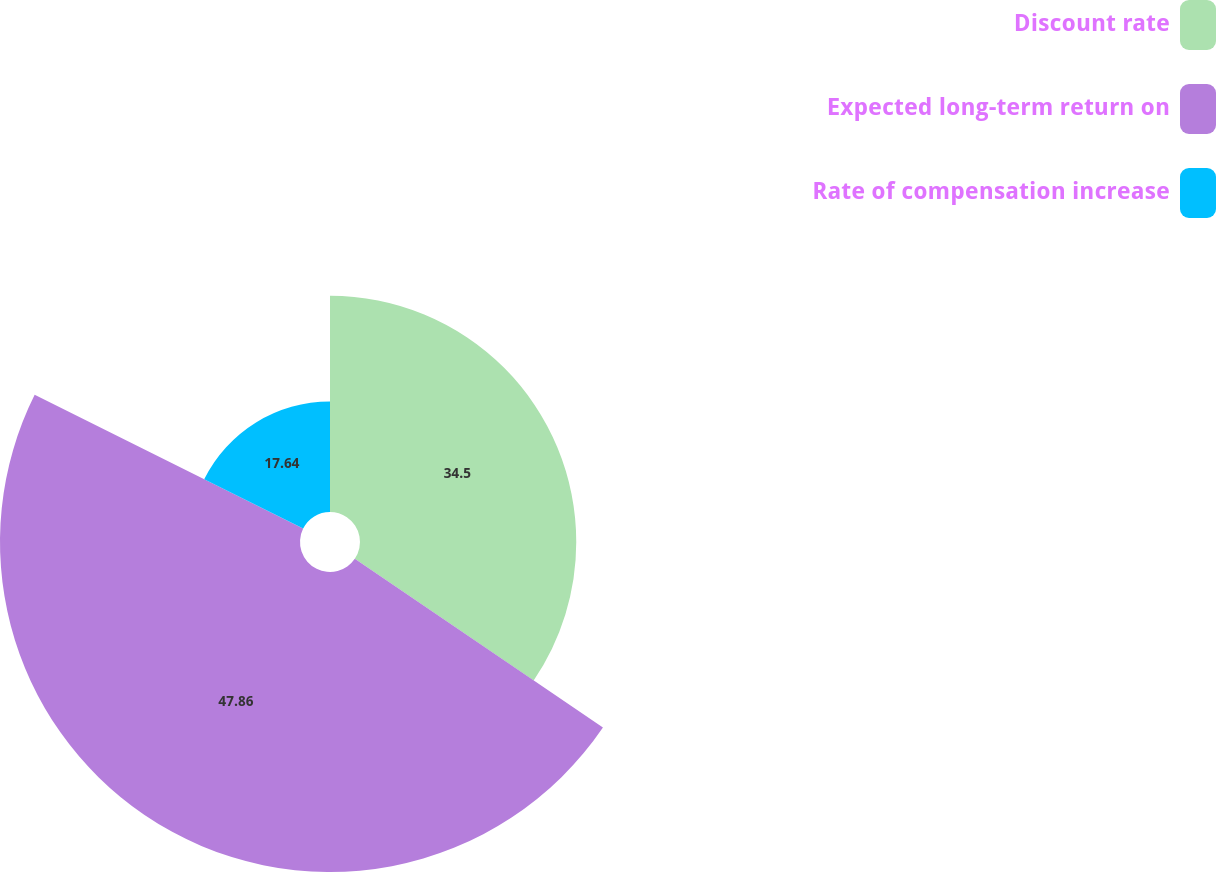Convert chart. <chart><loc_0><loc_0><loc_500><loc_500><pie_chart><fcel>Discount rate<fcel>Expected long-term return on<fcel>Rate of compensation increase<nl><fcel>34.5%<fcel>47.86%<fcel>17.64%<nl></chart> 